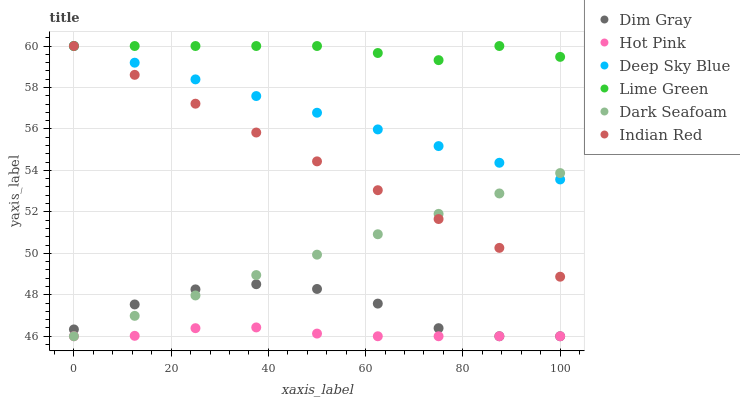Does Hot Pink have the minimum area under the curve?
Answer yes or no. Yes. Does Lime Green have the maximum area under the curve?
Answer yes or no. Yes. Does Deep Sky Blue have the minimum area under the curve?
Answer yes or no. No. Does Deep Sky Blue have the maximum area under the curve?
Answer yes or no. No. Is Indian Red the smoothest?
Answer yes or no. Yes. Is Dim Gray the roughest?
Answer yes or no. Yes. Is Deep Sky Blue the smoothest?
Answer yes or no. No. Is Deep Sky Blue the roughest?
Answer yes or no. No. Does Dim Gray have the lowest value?
Answer yes or no. Yes. Does Deep Sky Blue have the lowest value?
Answer yes or no. No. Does Lime Green have the highest value?
Answer yes or no. Yes. Does Hot Pink have the highest value?
Answer yes or no. No. Is Dim Gray less than Lime Green?
Answer yes or no. Yes. Is Lime Green greater than Dim Gray?
Answer yes or no. Yes. Does Dim Gray intersect Dark Seafoam?
Answer yes or no. Yes. Is Dim Gray less than Dark Seafoam?
Answer yes or no. No. Is Dim Gray greater than Dark Seafoam?
Answer yes or no. No. Does Dim Gray intersect Lime Green?
Answer yes or no. No. 